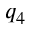<formula> <loc_0><loc_0><loc_500><loc_500>q _ { 4 }</formula> 